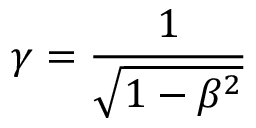<formula> <loc_0><loc_0><loc_500><loc_500>\gamma = \frac { 1 } { \sqrt { 1 - \beta ^ { 2 } } }</formula> 